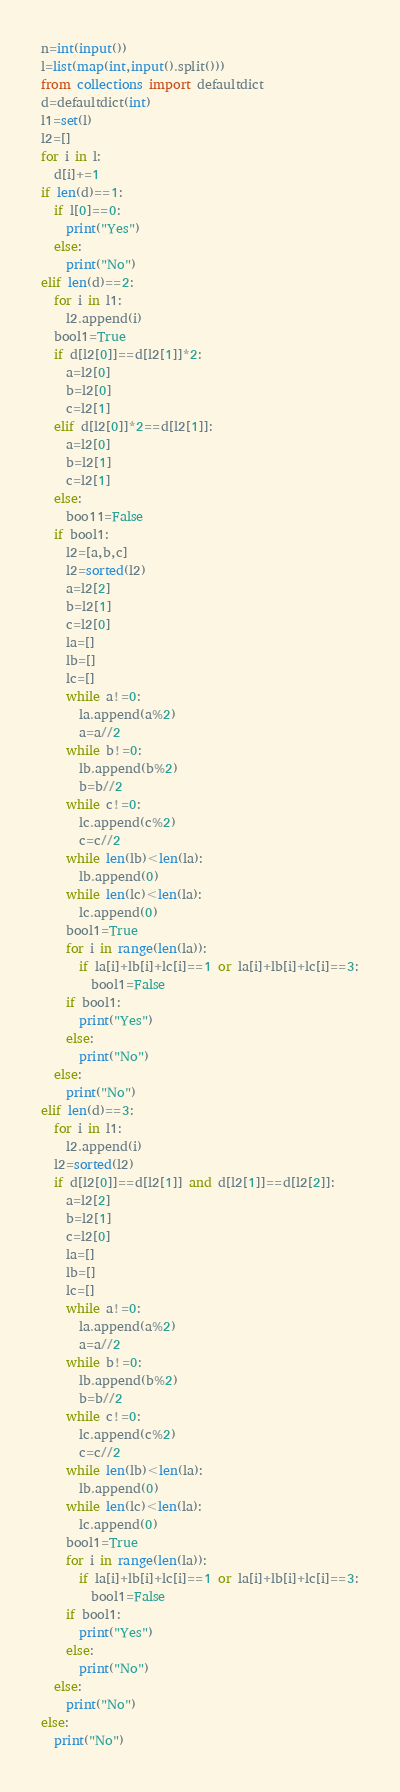Convert code to text. <code><loc_0><loc_0><loc_500><loc_500><_Python_>n=int(input())
l=list(map(int,input().split()))
from collections import defaultdict
d=defaultdict(int)
l1=set(l)
l2=[]
for i in l:
  d[i]+=1
if len(d)==1:
  if l[0]==0:
    print("Yes")
  else:
    print("No")
elif len(d)==2:
  for i in l1:
    l2.append(i)
  bool1=True
  if d[l2[0]]==d[l2[1]]*2:
    a=l2[0]
    b=l2[0]
    c=l2[1]
  elif d[l2[0]]*2==d[l2[1]]:
    a=l2[0]
    b=l2[1]
    c=l2[1]
  else:
    boo11=False
  if bool1:
    l2=[a,b,c]
    l2=sorted(l2)
    a=l2[2]
    b=l2[1]
    c=l2[0]
    la=[]
    lb=[]
    lc=[]
    while a!=0:
      la.append(a%2)
      a=a//2
    while b!=0:
      lb.append(b%2)
      b=b//2
    while c!=0:
      lc.append(c%2)
      c=c//2
    while len(lb)<len(la):
      lb.append(0)
    while len(lc)<len(la):
      lc.append(0)
    bool1=True
    for i in range(len(la)):
      if la[i]+lb[i]+lc[i]==1 or la[i]+lb[i]+lc[i]==3:
        bool1=False
    if bool1:
      print("Yes")
    else:
      print("No")
  else:
    print("No")  
elif len(d)==3:
  for i in l1:
    l2.append(i)
  l2=sorted(l2)
  if d[l2[0]]==d[l2[1]] and d[l2[1]]==d[l2[2]]:
    a=l2[2]
    b=l2[1]
    c=l2[0]
    la=[]
    lb=[]
    lc=[]
    while a!=0:
      la.append(a%2)
      a=a//2
    while b!=0:
      lb.append(b%2)
      b=b//2
    while c!=0:
      lc.append(c%2)
      c=c//2
    while len(lb)<len(la):
      lb.append(0)
    while len(lc)<len(la):
      lc.append(0)
    bool1=True
    for i in range(len(la)):
      if la[i]+lb[i]+lc[i]==1 or la[i]+lb[i]+lc[i]==3:
        bool1=False
    if bool1:
      print("Yes")
    else:
      print("No")           
  else:
    print("No")
else:
  print("No")</code> 